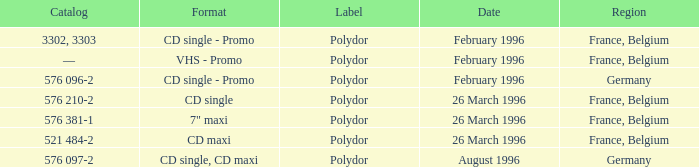Tell me the region for catalog of 576 096-2 Germany. 